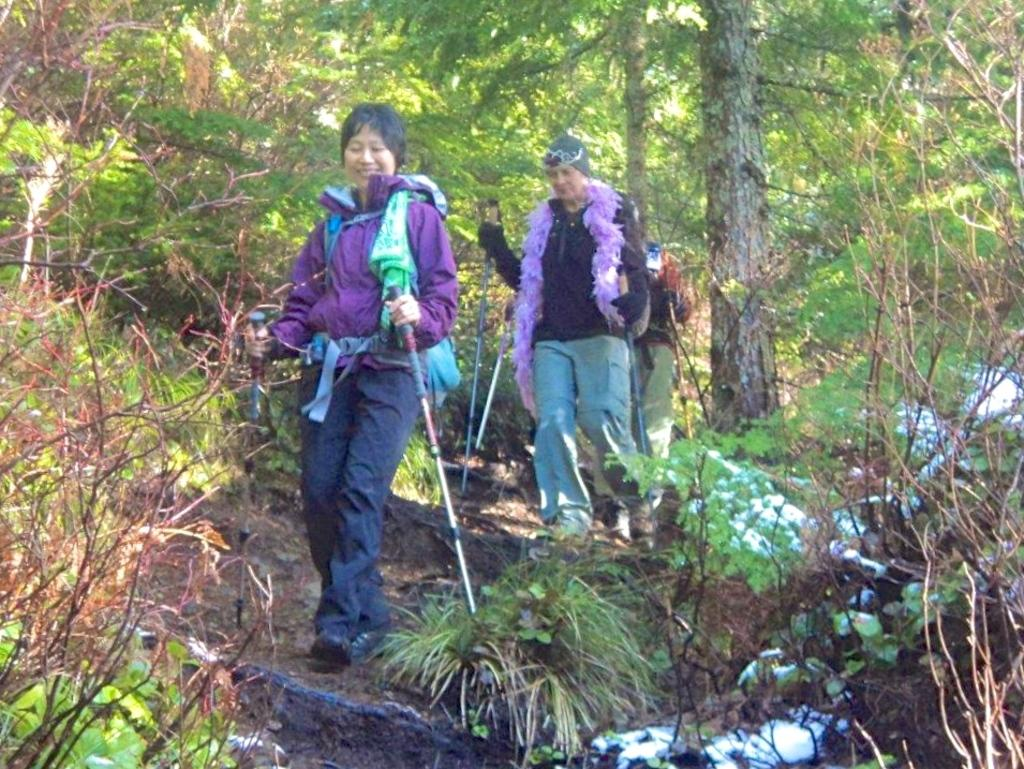How many people are in the image? There are three persons in the image. What are the persons doing in the image? The persons are walking. What are the persons holding in the image? The persons are holding objects. What can be seen in the background of the image? There are trees and plants in the background of the image. What type of mine can be seen in the background of the image? There is no mine present in the image; the background features trees and plants. 